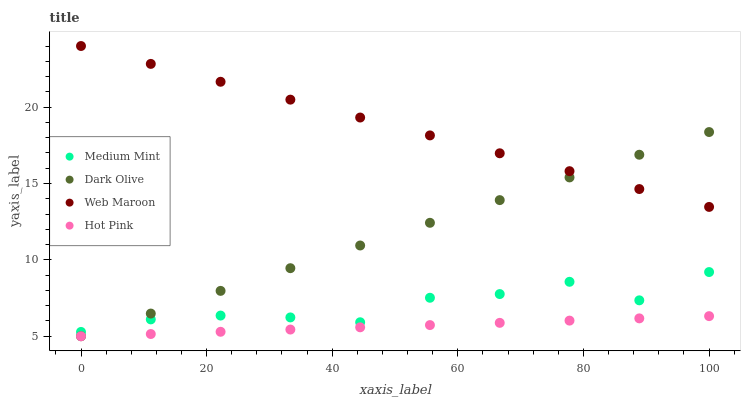Does Hot Pink have the minimum area under the curve?
Answer yes or no. Yes. Does Web Maroon have the maximum area under the curve?
Answer yes or no. Yes. Does Dark Olive have the minimum area under the curve?
Answer yes or no. No. Does Dark Olive have the maximum area under the curve?
Answer yes or no. No. Is Hot Pink the smoothest?
Answer yes or no. Yes. Is Medium Mint the roughest?
Answer yes or no. Yes. Is Dark Olive the smoothest?
Answer yes or no. No. Is Dark Olive the roughest?
Answer yes or no. No. Does Dark Olive have the lowest value?
Answer yes or no. Yes. Does Web Maroon have the lowest value?
Answer yes or no. No. Does Web Maroon have the highest value?
Answer yes or no. Yes. Does Dark Olive have the highest value?
Answer yes or no. No. Is Hot Pink less than Web Maroon?
Answer yes or no. Yes. Is Web Maroon greater than Medium Mint?
Answer yes or no. Yes. Does Dark Olive intersect Medium Mint?
Answer yes or no. Yes. Is Dark Olive less than Medium Mint?
Answer yes or no. No. Is Dark Olive greater than Medium Mint?
Answer yes or no. No. Does Hot Pink intersect Web Maroon?
Answer yes or no. No. 